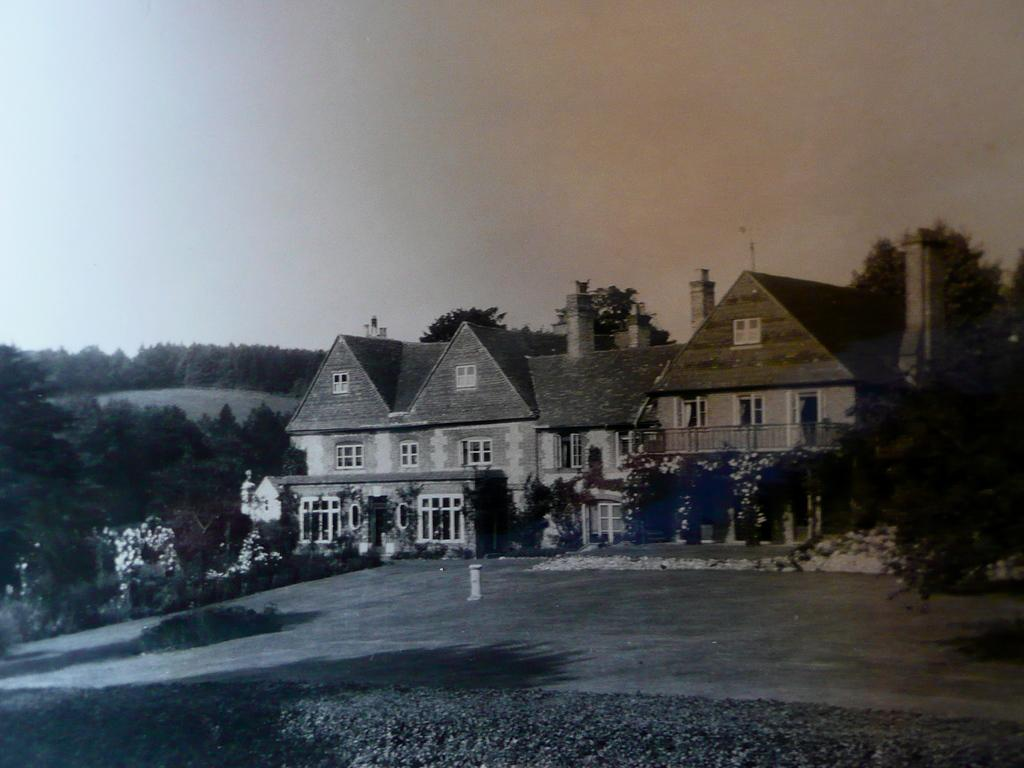What type of image is being described? The image is an old picture. What can be seen at the bottom of the image? There is a road at the bottom of the image. What is located beside the road? There is a building beside the road. What type of natural elements are visible in the image? Trees are visible in the image. What is visible at the top of the image? The sky is visible at the top of the image. What type of marble is being used to pave the road in the image? There is no mention of marble being used to pave the road in the image; it is simply a road. Can you see the person taking the selfie in the image? There is no mention of a selfie or a person taking a selfie in the image. 